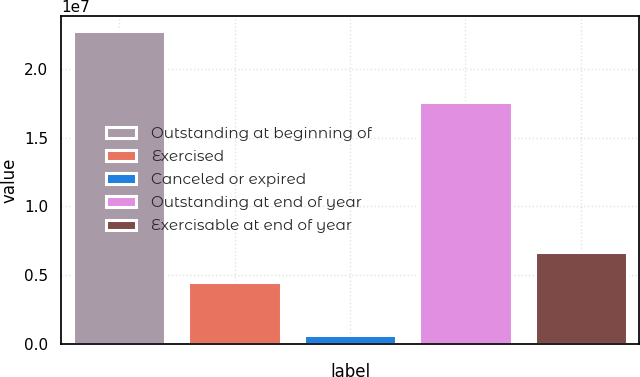<chart> <loc_0><loc_0><loc_500><loc_500><bar_chart><fcel>Outstanding at beginning of<fcel>Exercised<fcel>Canceled or expired<fcel>Outstanding at end of year<fcel>Exercisable at end of year<nl><fcel>2.2706e+07<fcel>4.4938e+06<fcel>632135<fcel>1.758e+07<fcel>6.70118e+06<nl></chart> 